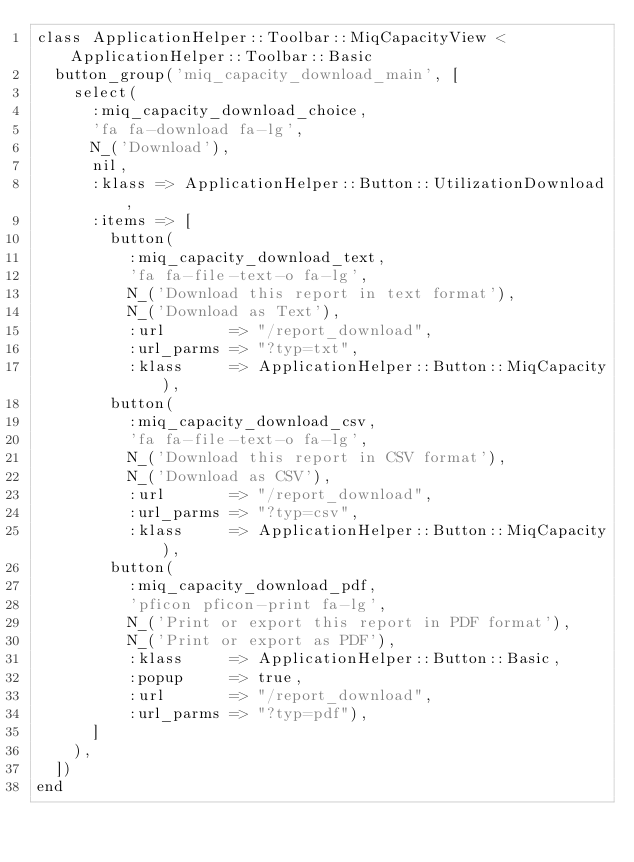Convert code to text. <code><loc_0><loc_0><loc_500><loc_500><_Ruby_>class ApplicationHelper::Toolbar::MiqCapacityView < ApplicationHelper::Toolbar::Basic
  button_group('miq_capacity_download_main', [
    select(
      :miq_capacity_download_choice,
      'fa fa-download fa-lg',
      N_('Download'),
      nil,
      :klass => ApplicationHelper::Button::UtilizationDownload,
      :items => [
        button(
          :miq_capacity_download_text,
          'fa fa-file-text-o fa-lg',
          N_('Download this report in text format'),
          N_('Download as Text'),
          :url       => "/report_download",
          :url_parms => "?typ=txt",
          :klass     => ApplicationHelper::Button::MiqCapacity),
        button(
          :miq_capacity_download_csv,
          'fa fa-file-text-o fa-lg',
          N_('Download this report in CSV format'),
          N_('Download as CSV'),
          :url       => "/report_download",
          :url_parms => "?typ=csv",
          :klass     => ApplicationHelper::Button::MiqCapacity),
        button(
          :miq_capacity_download_pdf,
          'pficon pficon-print fa-lg',
          N_('Print or export this report in PDF format'),
          N_('Print or export as PDF'),
          :klass     => ApplicationHelper::Button::Basic,
          :popup     => true,
          :url       => "/report_download",
          :url_parms => "?typ=pdf"),
      ]
    ),
  ])
end
</code> 